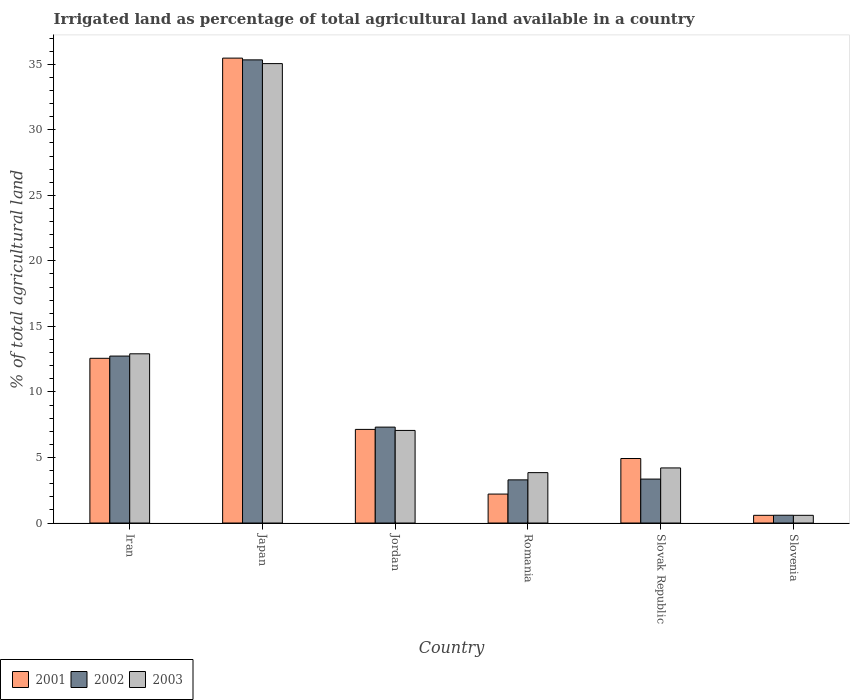How many different coloured bars are there?
Your answer should be compact. 3. How many groups of bars are there?
Keep it short and to the point. 6. Are the number of bars per tick equal to the number of legend labels?
Ensure brevity in your answer.  Yes. What is the label of the 3rd group of bars from the left?
Your answer should be very brief. Jordan. In how many cases, is the number of bars for a given country not equal to the number of legend labels?
Keep it short and to the point. 0. What is the percentage of irrigated land in 2002 in Iran?
Offer a very short reply. 12.74. Across all countries, what is the maximum percentage of irrigated land in 2002?
Ensure brevity in your answer.  35.33. Across all countries, what is the minimum percentage of irrigated land in 2002?
Your response must be concise. 0.59. In which country was the percentage of irrigated land in 2002 maximum?
Keep it short and to the point. Japan. In which country was the percentage of irrigated land in 2001 minimum?
Offer a terse response. Slovenia. What is the total percentage of irrigated land in 2002 in the graph?
Make the answer very short. 62.63. What is the difference between the percentage of irrigated land in 2002 in Jordan and that in Romania?
Provide a short and direct response. 4.02. What is the difference between the percentage of irrigated land in 2002 in Slovak Republic and the percentage of irrigated land in 2003 in Slovenia?
Offer a very short reply. 2.76. What is the average percentage of irrigated land in 2002 per country?
Your response must be concise. 10.44. What is the difference between the percentage of irrigated land of/in 2001 and percentage of irrigated land of/in 2002 in Jordan?
Keep it short and to the point. -0.17. In how many countries, is the percentage of irrigated land in 2002 greater than 8 %?
Your answer should be compact. 2. What is the ratio of the percentage of irrigated land in 2002 in Iran to that in Slovenia?
Your answer should be very brief. 21.44. Is the percentage of irrigated land in 2001 in Japan less than that in Slovenia?
Provide a short and direct response. No. What is the difference between the highest and the second highest percentage of irrigated land in 2002?
Ensure brevity in your answer.  22.6. What is the difference between the highest and the lowest percentage of irrigated land in 2002?
Your response must be concise. 34.74. What does the 3rd bar from the right in Slovenia represents?
Your answer should be very brief. 2001. Is it the case that in every country, the sum of the percentage of irrigated land in 2001 and percentage of irrigated land in 2002 is greater than the percentage of irrigated land in 2003?
Your answer should be very brief. Yes. How many bars are there?
Make the answer very short. 18. What is the difference between two consecutive major ticks on the Y-axis?
Provide a short and direct response. 5. Are the values on the major ticks of Y-axis written in scientific E-notation?
Keep it short and to the point. No. Does the graph contain grids?
Ensure brevity in your answer.  No. Where does the legend appear in the graph?
Keep it short and to the point. Bottom left. How many legend labels are there?
Your response must be concise. 3. What is the title of the graph?
Keep it short and to the point. Irrigated land as percentage of total agricultural land available in a country. Does "1981" appear as one of the legend labels in the graph?
Provide a succinct answer. No. What is the label or title of the X-axis?
Provide a short and direct response. Country. What is the label or title of the Y-axis?
Provide a succinct answer. % of total agricultural land. What is the % of total agricultural land in 2001 in Iran?
Provide a succinct answer. 12.57. What is the % of total agricultural land of 2002 in Iran?
Give a very brief answer. 12.74. What is the % of total agricultural land in 2003 in Iran?
Offer a very short reply. 12.91. What is the % of total agricultural land of 2001 in Japan?
Keep it short and to the point. 35.47. What is the % of total agricultural land in 2002 in Japan?
Provide a succinct answer. 35.33. What is the % of total agricultural land of 2003 in Japan?
Provide a short and direct response. 35.05. What is the % of total agricultural land of 2001 in Jordan?
Your answer should be very brief. 7.14. What is the % of total agricultural land of 2002 in Jordan?
Provide a succinct answer. 7.32. What is the % of total agricultural land of 2003 in Jordan?
Offer a terse response. 7.06. What is the % of total agricultural land in 2001 in Romania?
Keep it short and to the point. 2.21. What is the % of total agricultural land of 2002 in Romania?
Give a very brief answer. 3.29. What is the % of total agricultural land in 2003 in Romania?
Provide a succinct answer. 3.84. What is the % of total agricultural land of 2001 in Slovak Republic?
Make the answer very short. 4.92. What is the % of total agricultural land of 2002 in Slovak Republic?
Your answer should be compact. 3.35. What is the % of total agricultural land of 2003 in Slovak Republic?
Make the answer very short. 4.2. What is the % of total agricultural land in 2001 in Slovenia?
Provide a succinct answer. 0.59. What is the % of total agricultural land in 2002 in Slovenia?
Provide a succinct answer. 0.59. What is the % of total agricultural land in 2003 in Slovenia?
Make the answer very short. 0.59. Across all countries, what is the maximum % of total agricultural land in 2001?
Your response must be concise. 35.47. Across all countries, what is the maximum % of total agricultural land of 2002?
Ensure brevity in your answer.  35.33. Across all countries, what is the maximum % of total agricultural land in 2003?
Keep it short and to the point. 35.05. Across all countries, what is the minimum % of total agricultural land in 2001?
Provide a succinct answer. 0.59. Across all countries, what is the minimum % of total agricultural land of 2002?
Your response must be concise. 0.59. Across all countries, what is the minimum % of total agricultural land of 2003?
Give a very brief answer. 0.59. What is the total % of total agricultural land of 2001 in the graph?
Give a very brief answer. 62.9. What is the total % of total agricultural land of 2002 in the graph?
Provide a short and direct response. 62.63. What is the total % of total agricultural land in 2003 in the graph?
Your answer should be very brief. 63.66. What is the difference between the % of total agricultural land in 2001 in Iran and that in Japan?
Your answer should be compact. -22.9. What is the difference between the % of total agricultural land of 2002 in Iran and that in Japan?
Make the answer very short. -22.6. What is the difference between the % of total agricultural land in 2003 in Iran and that in Japan?
Make the answer very short. -22.14. What is the difference between the % of total agricultural land in 2001 in Iran and that in Jordan?
Ensure brevity in your answer.  5.42. What is the difference between the % of total agricultural land in 2002 in Iran and that in Jordan?
Provide a succinct answer. 5.42. What is the difference between the % of total agricultural land in 2003 in Iran and that in Jordan?
Provide a succinct answer. 5.85. What is the difference between the % of total agricultural land in 2001 in Iran and that in Romania?
Your answer should be very brief. 10.36. What is the difference between the % of total agricultural land in 2002 in Iran and that in Romania?
Provide a succinct answer. 9.44. What is the difference between the % of total agricultural land in 2003 in Iran and that in Romania?
Provide a succinct answer. 9.07. What is the difference between the % of total agricultural land in 2001 in Iran and that in Slovak Republic?
Your answer should be compact. 7.65. What is the difference between the % of total agricultural land in 2002 in Iran and that in Slovak Republic?
Offer a terse response. 9.39. What is the difference between the % of total agricultural land in 2003 in Iran and that in Slovak Republic?
Keep it short and to the point. 8.71. What is the difference between the % of total agricultural land in 2001 in Iran and that in Slovenia?
Give a very brief answer. 11.98. What is the difference between the % of total agricultural land of 2002 in Iran and that in Slovenia?
Your response must be concise. 12.14. What is the difference between the % of total agricultural land in 2003 in Iran and that in Slovenia?
Offer a terse response. 12.32. What is the difference between the % of total agricultural land in 2001 in Japan and that in Jordan?
Provide a succinct answer. 28.33. What is the difference between the % of total agricultural land of 2002 in Japan and that in Jordan?
Keep it short and to the point. 28.02. What is the difference between the % of total agricultural land in 2003 in Japan and that in Jordan?
Make the answer very short. 27.99. What is the difference between the % of total agricultural land of 2001 in Japan and that in Romania?
Give a very brief answer. 33.26. What is the difference between the % of total agricultural land in 2002 in Japan and that in Romania?
Provide a succinct answer. 32.04. What is the difference between the % of total agricultural land of 2003 in Japan and that in Romania?
Your answer should be compact. 31.21. What is the difference between the % of total agricultural land in 2001 in Japan and that in Slovak Republic?
Your answer should be compact. 30.55. What is the difference between the % of total agricultural land of 2002 in Japan and that in Slovak Republic?
Offer a very short reply. 31.98. What is the difference between the % of total agricultural land of 2003 in Japan and that in Slovak Republic?
Give a very brief answer. 30.85. What is the difference between the % of total agricultural land of 2001 in Japan and that in Slovenia?
Offer a very short reply. 34.88. What is the difference between the % of total agricultural land in 2002 in Japan and that in Slovenia?
Your answer should be compact. 34.74. What is the difference between the % of total agricultural land of 2003 in Japan and that in Slovenia?
Provide a succinct answer. 34.46. What is the difference between the % of total agricultural land in 2001 in Jordan and that in Romania?
Keep it short and to the point. 4.93. What is the difference between the % of total agricultural land of 2002 in Jordan and that in Romania?
Give a very brief answer. 4.02. What is the difference between the % of total agricultural land of 2003 in Jordan and that in Romania?
Your response must be concise. 3.22. What is the difference between the % of total agricultural land of 2001 in Jordan and that in Slovak Republic?
Offer a terse response. 2.22. What is the difference between the % of total agricultural land in 2002 in Jordan and that in Slovak Republic?
Provide a succinct answer. 3.96. What is the difference between the % of total agricultural land in 2003 in Jordan and that in Slovak Republic?
Make the answer very short. 2.86. What is the difference between the % of total agricultural land in 2001 in Jordan and that in Slovenia?
Offer a very short reply. 6.55. What is the difference between the % of total agricultural land in 2002 in Jordan and that in Slovenia?
Offer a very short reply. 6.72. What is the difference between the % of total agricultural land in 2003 in Jordan and that in Slovenia?
Provide a short and direct response. 6.48. What is the difference between the % of total agricultural land in 2001 in Romania and that in Slovak Republic?
Offer a very short reply. -2.71. What is the difference between the % of total agricultural land of 2002 in Romania and that in Slovak Republic?
Make the answer very short. -0.06. What is the difference between the % of total agricultural land in 2003 in Romania and that in Slovak Republic?
Offer a very short reply. -0.36. What is the difference between the % of total agricultural land of 2001 in Romania and that in Slovenia?
Provide a short and direct response. 1.62. What is the difference between the % of total agricultural land of 2002 in Romania and that in Slovenia?
Your response must be concise. 2.7. What is the difference between the % of total agricultural land in 2003 in Romania and that in Slovenia?
Offer a very short reply. 3.26. What is the difference between the % of total agricultural land of 2001 in Slovak Republic and that in Slovenia?
Ensure brevity in your answer.  4.33. What is the difference between the % of total agricultural land in 2002 in Slovak Republic and that in Slovenia?
Ensure brevity in your answer.  2.76. What is the difference between the % of total agricultural land in 2003 in Slovak Republic and that in Slovenia?
Offer a very short reply. 3.62. What is the difference between the % of total agricultural land in 2001 in Iran and the % of total agricultural land in 2002 in Japan?
Your answer should be compact. -22.77. What is the difference between the % of total agricultural land in 2001 in Iran and the % of total agricultural land in 2003 in Japan?
Provide a short and direct response. -22.48. What is the difference between the % of total agricultural land of 2002 in Iran and the % of total agricultural land of 2003 in Japan?
Make the answer very short. -22.31. What is the difference between the % of total agricultural land of 2001 in Iran and the % of total agricultural land of 2002 in Jordan?
Your answer should be very brief. 5.25. What is the difference between the % of total agricultural land of 2001 in Iran and the % of total agricultural land of 2003 in Jordan?
Provide a short and direct response. 5.5. What is the difference between the % of total agricultural land in 2002 in Iran and the % of total agricultural land in 2003 in Jordan?
Make the answer very short. 5.67. What is the difference between the % of total agricultural land of 2001 in Iran and the % of total agricultural land of 2002 in Romania?
Make the answer very short. 9.27. What is the difference between the % of total agricultural land of 2001 in Iran and the % of total agricultural land of 2003 in Romania?
Keep it short and to the point. 8.72. What is the difference between the % of total agricultural land in 2002 in Iran and the % of total agricultural land in 2003 in Romania?
Your answer should be compact. 8.89. What is the difference between the % of total agricultural land of 2001 in Iran and the % of total agricultural land of 2002 in Slovak Republic?
Make the answer very short. 9.21. What is the difference between the % of total agricultural land of 2001 in Iran and the % of total agricultural land of 2003 in Slovak Republic?
Give a very brief answer. 8.36. What is the difference between the % of total agricultural land in 2002 in Iran and the % of total agricultural land in 2003 in Slovak Republic?
Provide a succinct answer. 8.53. What is the difference between the % of total agricultural land in 2001 in Iran and the % of total agricultural land in 2002 in Slovenia?
Your answer should be very brief. 11.97. What is the difference between the % of total agricultural land in 2001 in Iran and the % of total agricultural land in 2003 in Slovenia?
Your response must be concise. 11.98. What is the difference between the % of total agricultural land of 2002 in Iran and the % of total agricultural land of 2003 in Slovenia?
Offer a terse response. 12.15. What is the difference between the % of total agricultural land in 2001 in Japan and the % of total agricultural land in 2002 in Jordan?
Make the answer very short. 28.15. What is the difference between the % of total agricultural land of 2001 in Japan and the % of total agricultural land of 2003 in Jordan?
Your answer should be very brief. 28.4. What is the difference between the % of total agricultural land in 2002 in Japan and the % of total agricultural land in 2003 in Jordan?
Your answer should be compact. 28.27. What is the difference between the % of total agricultural land in 2001 in Japan and the % of total agricultural land in 2002 in Romania?
Your response must be concise. 32.18. What is the difference between the % of total agricultural land of 2001 in Japan and the % of total agricultural land of 2003 in Romania?
Offer a very short reply. 31.62. What is the difference between the % of total agricultural land in 2002 in Japan and the % of total agricultural land in 2003 in Romania?
Provide a short and direct response. 31.49. What is the difference between the % of total agricultural land of 2001 in Japan and the % of total agricultural land of 2002 in Slovak Republic?
Provide a succinct answer. 32.12. What is the difference between the % of total agricultural land of 2001 in Japan and the % of total agricultural land of 2003 in Slovak Republic?
Your answer should be compact. 31.26. What is the difference between the % of total agricultural land in 2002 in Japan and the % of total agricultural land in 2003 in Slovak Republic?
Your answer should be compact. 31.13. What is the difference between the % of total agricultural land in 2001 in Japan and the % of total agricultural land in 2002 in Slovenia?
Provide a short and direct response. 34.87. What is the difference between the % of total agricultural land of 2001 in Japan and the % of total agricultural land of 2003 in Slovenia?
Offer a very short reply. 34.88. What is the difference between the % of total agricultural land of 2002 in Japan and the % of total agricultural land of 2003 in Slovenia?
Your response must be concise. 34.75. What is the difference between the % of total agricultural land in 2001 in Jordan and the % of total agricultural land in 2002 in Romania?
Offer a very short reply. 3.85. What is the difference between the % of total agricultural land of 2001 in Jordan and the % of total agricultural land of 2003 in Romania?
Give a very brief answer. 3.3. What is the difference between the % of total agricultural land in 2002 in Jordan and the % of total agricultural land in 2003 in Romania?
Your answer should be very brief. 3.47. What is the difference between the % of total agricultural land of 2001 in Jordan and the % of total agricultural land of 2002 in Slovak Republic?
Your answer should be very brief. 3.79. What is the difference between the % of total agricultural land in 2001 in Jordan and the % of total agricultural land in 2003 in Slovak Republic?
Provide a succinct answer. 2.94. What is the difference between the % of total agricultural land in 2002 in Jordan and the % of total agricultural land in 2003 in Slovak Republic?
Your answer should be compact. 3.11. What is the difference between the % of total agricultural land in 2001 in Jordan and the % of total agricultural land in 2002 in Slovenia?
Ensure brevity in your answer.  6.55. What is the difference between the % of total agricultural land in 2001 in Jordan and the % of total agricultural land in 2003 in Slovenia?
Your response must be concise. 6.55. What is the difference between the % of total agricultural land of 2002 in Jordan and the % of total agricultural land of 2003 in Slovenia?
Your response must be concise. 6.73. What is the difference between the % of total agricultural land of 2001 in Romania and the % of total agricultural land of 2002 in Slovak Republic?
Your response must be concise. -1.14. What is the difference between the % of total agricultural land in 2001 in Romania and the % of total agricultural land in 2003 in Slovak Republic?
Provide a succinct answer. -1.99. What is the difference between the % of total agricultural land in 2002 in Romania and the % of total agricultural land in 2003 in Slovak Republic?
Your answer should be very brief. -0.91. What is the difference between the % of total agricultural land in 2001 in Romania and the % of total agricultural land in 2002 in Slovenia?
Your answer should be compact. 1.62. What is the difference between the % of total agricultural land in 2001 in Romania and the % of total agricultural land in 2003 in Slovenia?
Give a very brief answer. 1.62. What is the difference between the % of total agricultural land of 2002 in Romania and the % of total agricultural land of 2003 in Slovenia?
Offer a very short reply. 2.71. What is the difference between the % of total agricultural land in 2001 in Slovak Republic and the % of total agricultural land in 2002 in Slovenia?
Offer a very short reply. 4.33. What is the difference between the % of total agricultural land in 2001 in Slovak Republic and the % of total agricultural land in 2003 in Slovenia?
Your response must be concise. 4.33. What is the difference between the % of total agricultural land of 2002 in Slovak Republic and the % of total agricultural land of 2003 in Slovenia?
Your answer should be very brief. 2.76. What is the average % of total agricultural land of 2001 per country?
Your response must be concise. 10.48. What is the average % of total agricultural land in 2002 per country?
Offer a terse response. 10.44. What is the average % of total agricultural land of 2003 per country?
Your answer should be compact. 10.61. What is the difference between the % of total agricultural land of 2001 and % of total agricultural land of 2002 in Iran?
Provide a succinct answer. -0.17. What is the difference between the % of total agricultural land of 2001 and % of total agricultural land of 2003 in Iran?
Offer a terse response. -0.34. What is the difference between the % of total agricultural land in 2002 and % of total agricultural land in 2003 in Iran?
Your answer should be very brief. -0.17. What is the difference between the % of total agricultural land of 2001 and % of total agricultural land of 2002 in Japan?
Your response must be concise. 0.13. What is the difference between the % of total agricultural land of 2001 and % of total agricultural land of 2003 in Japan?
Offer a very short reply. 0.42. What is the difference between the % of total agricultural land in 2002 and % of total agricultural land in 2003 in Japan?
Your response must be concise. 0.28. What is the difference between the % of total agricultural land of 2001 and % of total agricultural land of 2002 in Jordan?
Ensure brevity in your answer.  -0.17. What is the difference between the % of total agricultural land in 2001 and % of total agricultural land in 2003 in Jordan?
Offer a very short reply. 0.08. What is the difference between the % of total agricultural land of 2002 and % of total agricultural land of 2003 in Jordan?
Your answer should be compact. 0.25. What is the difference between the % of total agricultural land in 2001 and % of total agricultural land in 2002 in Romania?
Offer a terse response. -1.08. What is the difference between the % of total agricultural land in 2001 and % of total agricultural land in 2003 in Romania?
Your answer should be very brief. -1.63. What is the difference between the % of total agricultural land in 2002 and % of total agricultural land in 2003 in Romania?
Make the answer very short. -0.55. What is the difference between the % of total agricultural land in 2001 and % of total agricultural land in 2002 in Slovak Republic?
Make the answer very short. 1.57. What is the difference between the % of total agricultural land in 2001 and % of total agricultural land in 2003 in Slovak Republic?
Your response must be concise. 0.72. What is the difference between the % of total agricultural land of 2002 and % of total agricultural land of 2003 in Slovak Republic?
Offer a terse response. -0.85. What is the difference between the % of total agricultural land in 2001 and % of total agricultural land in 2002 in Slovenia?
Your answer should be very brief. -0.01. What is the difference between the % of total agricultural land of 2001 and % of total agricultural land of 2003 in Slovenia?
Offer a very short reply. 0. What is the difference between the % of total agricultural land of 2002 and % of total agricultural land of 2003 in Slovenia?
Keep it short and to the point. 0.01. What is the ratio of the % of total agricultural land in 2001 in Iran to that in Japan?
Ensure brevity in your answer.  0.35. What is the ratio of the % of total agricultural land of 2002 in Iran to that in Japan?
Make the answer very short. 0.36. What is the ratio of the % of total agricultural land of 2003 in Iran to that in Japan?
Provide a succinct answer. 0.37. What is the ratio of the % of total agricultural land in 2001 in Iran to that in Jordan?
Your response must be concise. 1.76. What is the ratio of the % of total agricultural land of 2002 in Iran to that in Jordan?
Ensure brevity in your answer.  1.74. What is the ratio of the % of total agricultural land in 2003 in Iran to that in Jordan?
Give a very brief answer. 1.83. What is the ratio of the % of total agricultural land of 2001 in Iran to that in Romania?
Provide a short and direct response. 5.69. What is the ratio of the % of total agricultural land of 2002 in Iran to that in Romania?
Your answer should be very brief. 3.87. What is the ratio of the % of total agricultural land of 2003 in Iran to that in Romania?
Give a very brief answer. 3.36. What is the ratio of the % of total agricultural land in 2001 in Iran to that in Slovak Republic?
Your answer should be very brief. 2.55. What is the ratio of the % of total agricultural land in 2002 in Iran to that in Slovak Republic?
Offer a terse response. 3.8. What is the ratio of the % of total agricultural land in 2003 in Iran to that in Slovak Republic?
Ensure brevity in your answer.  3.07. What is the ratio of the % of total agricultural land of 2001 in Iran to that in Slovenia?
Your response must be concise. 21.36. What is the ratio of the % of total agricultural land in 2002 in Iran to that in Slovenia?
Your answer should be very brief. 21.44. What is the ratio of the % of total agricultural land of 2003 in Iran to that in Slovenia?
Give a very brief answer. 21.95. What is the ratio of the % of total agricultural land in 2001 in Japan to that in Jordan?
Make the answer very short. 4.97. What is the ratio of the % of total agricultural land of 2002 in Japan to that in Jordan?
Offer a very short reply. 4.83. What is the ratio of the % of total agricultural land of 2003 in Japan to that in Jordan?
Your answer should be very brief. 4.96. What is the ratio of the % of total agricultural land in 2001 in Japan to that in Romania?
Offer a terse response. 16.05. What is the ratio of the % of total agricultural land in 2002 in Japan to that in Romania?
Your answer should be compact. 10.73. What is the ratio of the % of total agricultural land in 2003 in Japan to that in Romania?
Provide a succinct answer. 9.12. What is the ratio of the % of total agricultural land in 2001 in Japan to that in Slovak Republic?
Your answer should be very brief. 7.21. What is the ratio of the % of total agricultural land of 2002 in Japan to that in Slovak Republic?
Offer a very short reply. 10.54. What is the ratio of the % of total agricultural land of 2003 in Japan to that in Slovak Republic?
Provide a short and direct response. 8.34. What is the ratio of the % of total agricultural land of 2001 in Japan to that in Slovenia?
Your answer should be very brief. 60.3. What is the ratio of the % of total agricultural land of 2002 in Japan to that in Slovenia?
Provide a succinct answer. 59.48. What is the ratio of the % of total agricultural land in 2003 in Japan to that in Slovenia?
Your answer should be compact. 59.59. What is the ratio of the % of total agricultural land in 2001 in Jordan to that in Romania?
Make the answer very short. 3.23. What is the ratio of the % of total agricultural land in 2002 in Jordan to that in Romania?
Offer a very short reply. 2.22. What is the ratio of the % of total agricultural land in 2003 in Jordan to that in Romania?
Offer a terse response. 1.84. What is the ratio of the % of total agricultural land in 2001 in Jordan to that in Slovak Republic?
Your answer should be compact. 1.45. What is the ratio of the % of total agricultural land of 2002 in Jordan to that in Slovak Republic?
Your answer should be compact. 2.18. What is the ratio of the % of total agricultural land in 2003 in Jordan to that in Slovak Republic?
Make the answer very short. 1.68. What is the ratio of the % of total agricultural land in 2001 in Jordan to that in Slovenia?
Your answer should be compact. 12.14. What is the ratio of the % of total agricultural land in 2002 in Jordan to that in Slovenia?
Offer a very short reply. 12.32. What is the ratio of the % of total agricultural land of 2003 in Jordan to that in Slovenia?
Ensure brevity in your answer.  12.01. What is the ratio of the % of total agricultural land in 2001 in Romania to that in Slovak Republic?
Your answer should be very brief. 0.45. What is the ratio of the % of total agricultural land of 2002 in Romania to that in Slovak Republic?
Give a very brief answer. 0.98. What is the ratio of the % of total agricultural land of 2003 in Romania to that in Slovak Republic?
Provide a short and direct response. 0.91. What is the ratio of the % of total agricultural land of 2001 in Romania to that in Slovenia?
Offer a terse response. 3.76. What is the ratio of the % of total agricultural land of 2002 in Romania to that in Slovenia?
Keep it short and to the point. 5.54. What is the ratio of the % of total agricultural land of 2003 in Romania to that in Slovenia?
Keep it short and to the point. 6.54. What is the ratio of the % of total agricultural land in 2001 in Slovak Republic to that in Slovenia?
Your answer should be compact. 8.37. What is the ratio of the % of total agricultural land in 2002 in Slovak Republic to that in Slovenia?
Keep it short and to the point. 5.64. What is the ratio of the % of total agricultural land in 2003 in Slovak Republic to that in Slovenia?
Offer a terse response. 7.15. What is the difference between the highest and the second highest % of total agricultural land in 2001?
Provide a short and direct response. 22.9. What is the difference between the highest and the second highest % of total agricultural land in 2002?
Offer a terse response. 22.6. What is the difference between the highest and the second highest % of total agricultural land of 2003?
Provide a short and direct response. 22.14. What is the difference between the highest and the lowest % of total agricultural land in 2001?
Your response must be concise. 34.88. What is the difference between the highest and the lowest % of total agricultural land of 2002?
Your answer should be very brief. 34.74. What is the difference between the highest and the lowest % of total agricultural land of 2003?
Ensure brevity in your answer.  34.46. 